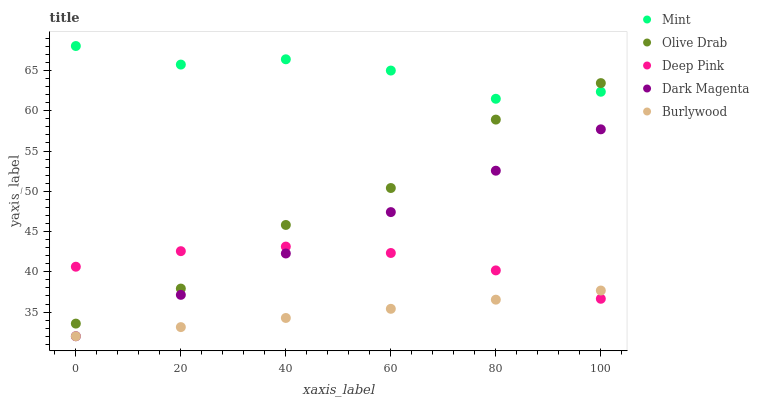Does Burlywood have the minimum area under the curve?
Answer yes or no. Yes. Does Mint have the maximum area under the curve?
Answer yes or no. Yes. Does Deep Pink have the minimum area under the curve?
Answer yes or no. No. Does Deep Pink have the maximum area under the curve?
Answer yes or no. No. Is Burlywood the smoothest?
Answer yes or no. Yes. Is Olive Drab the roughest?
Answer yes or no. Yes. Is Deep Pink the smoothest?
Answer yes or no. No. Is Deep Pink the roughest?
Answer yes or no. No. Does Burlywood have the lowest value?
Answer yes or no. Yes. Does Deep Pink have the lowest value?
Answer yes or no. No. Does Mint have the highest value?
Answer yes or no. Yes. Does Deep Pink have the highest value?
Answer yes or no. No. Is Burlywood less than Olive Drab?
Answer yes or no. Yes. Is Mint greater than Dark Magenta?
Answer yes or no. Yes. Does Deep Pink intersect Dark Magenta?
Answer yes or no. Yes. Is Deep Pink less than Dark Magenta?
Answer yes or no. No. Is Deep Pink greater than Dark Magenta?
Answer yes or no. No. Does Burlywood intersect Olive Drab?
Answer yes or no. No. 